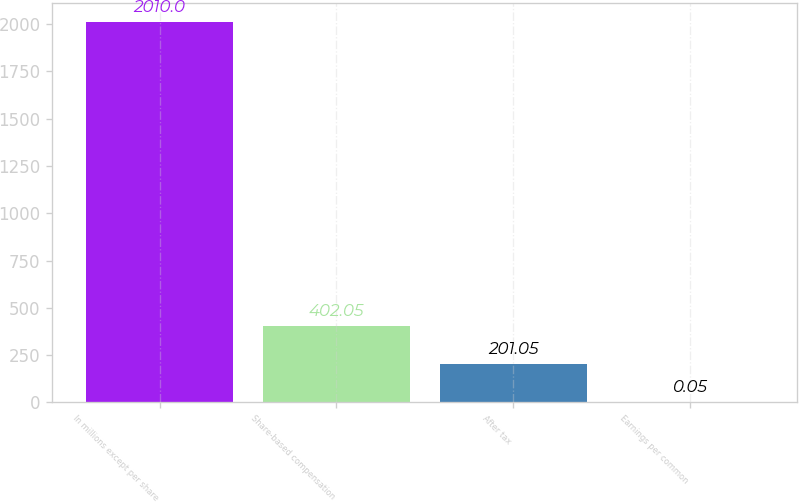Convert chart. <chart><loc_0><loc_0><loc_500><loc_500><bar_chart><fcel>In millions except per share<fcel>Share-based compensation<fcel>After tax<fcel>Earnings per common<nl><fcel>2010<fcel>402.05<fcel>201.05<fcel>0.05<nl></chart> 